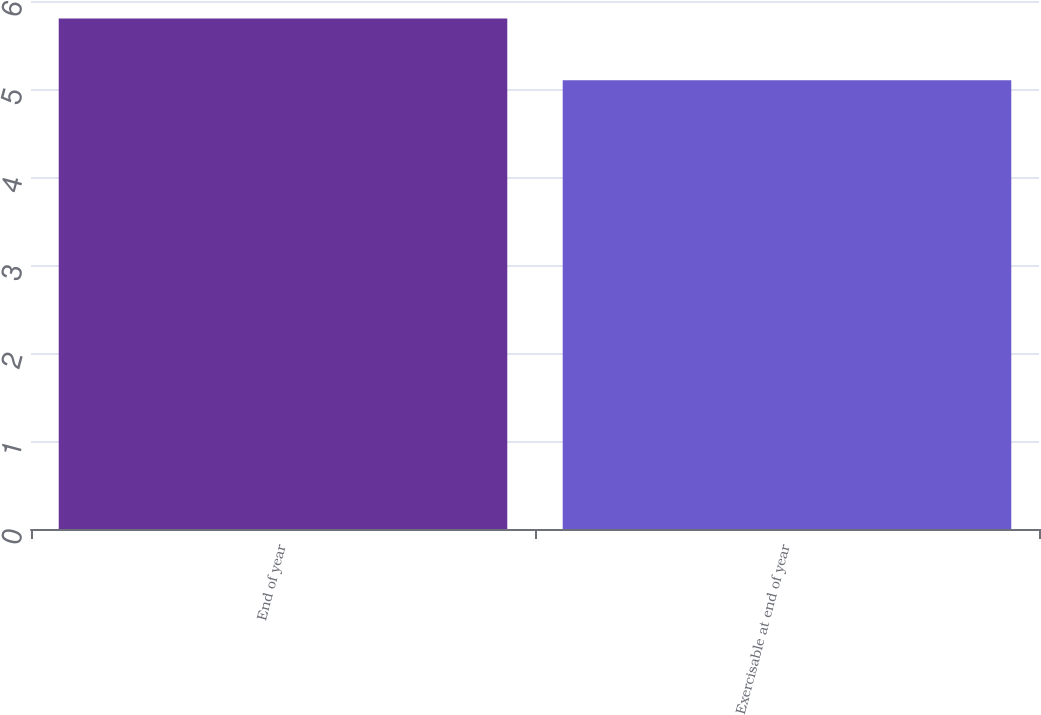<chart> <loc_0><loc_0><loc_500><loc_500><bar_chart><fcel>End of year<fcel>Exercisable at end of year<nl><fcel>5.8<fcel>5.1<nl></chart> 